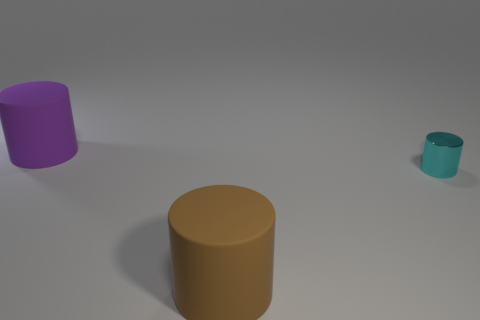What number of big cylinders are both in front of the tiny cyan shiny cylinder and behind the brown thing?
Provide a succinct answer. 0. What number of other objects are there of the same material as the cyan thing?
Offer a very short reply. 0. The big thing behind the rubber object in front of the large purple matte object is what color?
Make the answer very short. Purple. Does the large object that is in front of the big purple object have the same color as the tiny object?
Ensure brevity in your answer.  No. Do the brown rubber cylinder and the cyan metallic cylinder have the same size?
Give a very brief answer. No. The other object that is the same size as the purple object is what shape?
Provide a succinct answer. Cylinder. There is a rubber cylinder that is right of the purple object; does it have the same size as the tiny metal cylinder?
Give a very brief answer. No. What is the material of the thing that is the same size as the purple matte cylinder?
Provide a short and direct response. Rubber. Is there a purple thing behind the large matte thing left of the matte cylinder in front of the small metal object?
Give a very brief answer. No. Are there any other things that are the same shape as the small cyan thing?
Provide a short and direct response. Yes. 